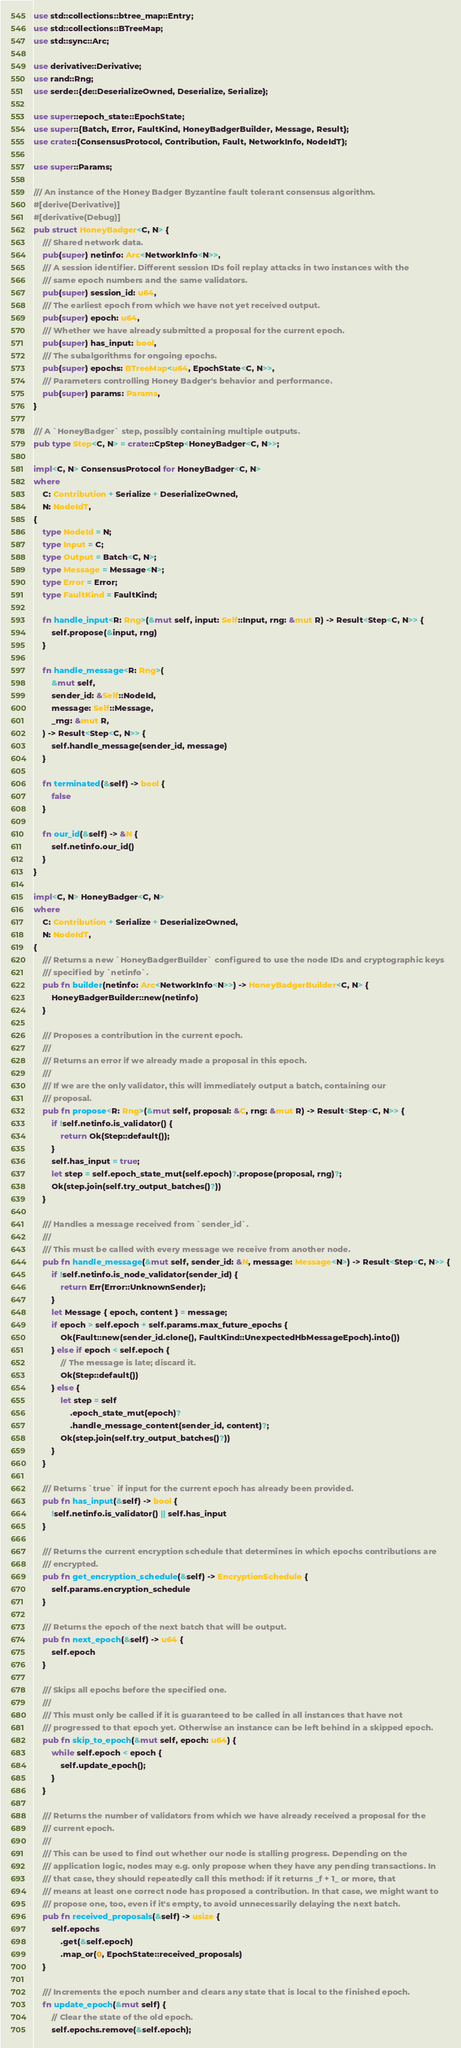Convert code to text. <code><loc_0><loc_0><loc_500><loc_500><_Rust_>use std::collections::btree_map::Entry;
use std::collections::BTreeMap;
use std::sync::Arc;

use derivative::Derivative;
use rand::Rng;
use serde::{de::DeserializeOwned, Deserialize, Serialize};

use super::epoch_state::EpochState;
use super::{Batch, Error, FaultKind, HoneyBadgerBuilder, Message, Result};
use crate::{ConsensusProtocol, Contribution, Fault, NetworkInfo, NodeIdT};

use super::Params;

/// An instance of the Honey Badger Byzantine fault tolerant consensus algorithm.
#[derive(Derivative)]
#[derivative(Debug)]
pub struct HoneyBadger<C, N> {
    /// Shared network data.
    pub(super) netinfo: Arc<NetworkInfo<N>>,
    /// A session identifier. Different session IDs foil replay attacks in two instances with the
    /// same epoch numbers and the same validators.
    pub(super) session_id: u64,
    /// The earliest epoch from which we have not yet received output.
    pub(super) epoch: u64,
    /// Whether we have already submitted a proposal for the current epoch.
    pub(super) has_input: bool,
    /// The subalgorithms for ongoing epochs.
    pub(super) epochs: BTreeMap<u64, EpochState<C, N>>,
    /// Parameters controlling Honey Badger's behavior and performance.
    pub(super) params: Params,
}

/// A `HoneyBadger` step, possibly containing multiple outputs.
pub type Step<C, N> = crate::CpStep<HoneyBadger<C, N>>;

impl<C, N> ConsensusProtocol for HoneyBadger<C, N>
where
    C: Contribution + Serialize + DeserializeOwned,
    N: NodeIdT,
{
    type NodeId = N;
    type Input = C;
    type Output = Batch<C, N>;
    type Message = Message<N>;
    type Error = Error;
    type FaultKind = FaultKind;

    fn handle_input<R: Rng>(&mut self, input: Self::Input, rng: &mut R) -> Result<Step<C, N>> {
        self.propose(&input, rng)
    }

    fn handle_message<R: Rng>(
        &mut self,
        sender_id: &Self::NodeId,
        message: Self::Message,
        _rng: &mut R,
    ) -> Result<Step<C, N>> {
        self.handle_message(sender_id, message)
    }

    fn terminated(&self) -> bool {
        false
    }

    fn our_id(&self) -> &N {
        self.netinfo.our_id()
    }
}

impl<C, N> HoneyBadger<C, N>
where
    C: Contribution + Serialize + DeserializeOwned,
    N: NodeIdT,
{
    /// Returns a new `HoneyBadgerBuilder` configured to use the node IDs and cryptographic keys
    /// specified by `netinfo`.
    pub fn builder(netinfo: Arc<NetworkInfo<N>>) -> HoneyBadgerBuilder<C, N> {
        HoneyBadgerBuilder::new(netinfo)
    }

    /// Proposes a contribution in the current epoch.
    ///
    /// Returns an error if we already made a proposal in this epoch.
    ///
    /// If we are the only validator, this will immediately output a batch, containing our
    /// proposal.
    pub fn propose<R: Rng>(&mut self, proposal: &C, rng: &mut R) -> Result<Step<C, N>> {
        if !self.netinfo.is_validator() {
            return Ok(Step::default());
        }
        self.has_input = true;
        let step = self.epoch_state_mut(self.epoch)?.propose(proposal, rng)?;
        Ok(step.join(self.try_output_batches()?))
    }

    /// Handles a message received from `sender_id`.
    ///
    /// This must be called with every message we receive from another node.
    pub fn handle_message(&mut self, sender_id: &N, message: Message<N>) -> Result<Step<C, N>> {
        if !self.netinfo.is_node_validator(sender_id) {
            return Err(Error::UnknownSender);
        }
        let Message { epoch, content } = message;
        if epoch > self.epoch + self.params.max_future_epochs {
            Ok(Fault::new(sender_id.clone(), FaultKind::UnexpectedHbMessageEpoch).into())
        } else if epoch < self.epoch {
            // The message is late; discard it.
            Ok(Step::default())
        } else {
            let step = self
                .epoch_state_mut(epoch)?
                .handle_message_content(sender_id, content)?;
            Ok(step.join(self.try_output_batches()?))
        }
    }

    /// Returns `true` if input for the current epoch has already been provided.
    pub fn has_input(&self) -> bool {
        !self.netinfo.is_validator() || self.has_input
    }

    /// Returns the current encryption schedule that determines in which epochs contributions are
    /// encrypted.
    pub fn get_encryption_schedule(&self) -> EncryptionSchedule {
        self.params.encryption_schedule
    }

    /// Returns the epoch of the next batch that will be output.
    pub fn next_epoch(&self) -> u64 {
        self.epoch
    }

    /// Skips all epochs before the specified one.
    ///
    /// This must only be called if it is guaranteed to be called in all instances that have not
    /// progressed to that epoch yet. Otherwise an instance can be left behind in a skipped epoch.
    pub fn skip_to_epoch(&mut self, epoch: u64) {
        while self.epoch < epoch {
            self.update_epoch();
        }
    }

    /// Returns the number of validators from which we have already received a proposal for the
    /// current epoch.
    ///
    /// This can be used to find out whether our node is stalling progress. Depending on the
    /// application logic, nodes may e.g. only propose when they have any pending transactions. In
    /// that case, they should repeatedly call this method: if it returns _f + 1_ or more, that
    /// means at least one correct node has proposed a contribution. In that case, we might want to
    /// propose one, too, even if it's empty, to avoid unnecessarily delaying the next batch.
    pub fn received_proposals(&self) -> usize {
        self.epochs
            .get(&self.epoch)
            .map_or(0, EpochState::received_proposals)
    }

    /// Increments the epoch number and clears any state that is local to the finished epoch.
    fn update_epoch(&mut self) {
        // Clear the state of the old epoch.
        self.epochs.remove(&self.epoch);</code> 